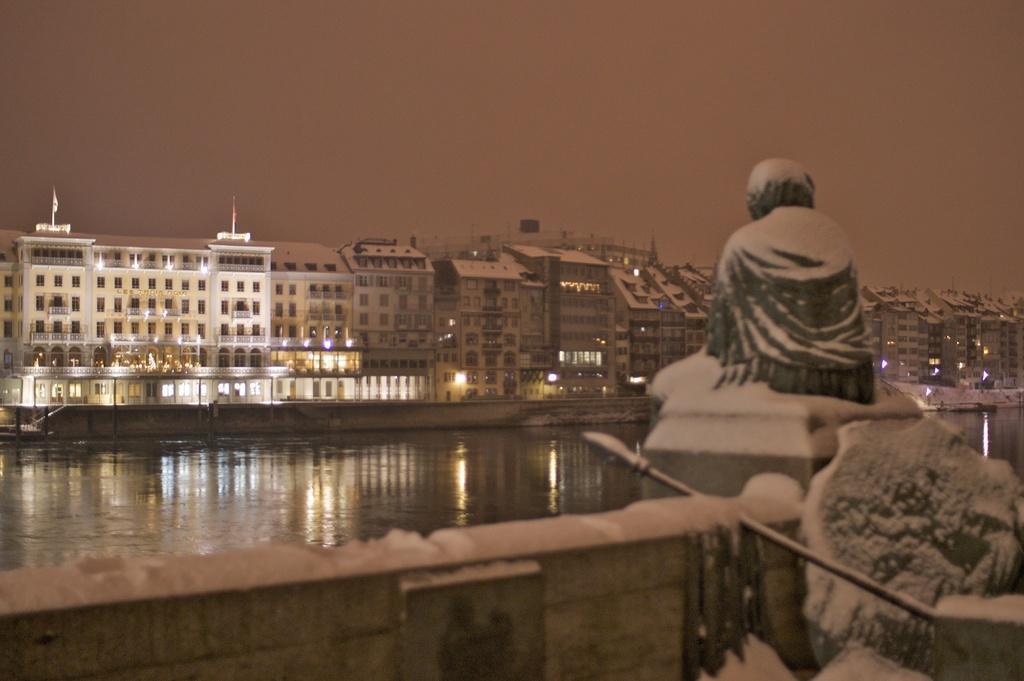What is the main subject in the image? There is a sculpture in the image. What else can be seen in the image besides the sculpture? There is a pole and objects on a platform in the image. What can be seen in the background of the image? Water, buildings, windows, and poles are visible in the background of the image. The sky is also visible. Can you see any eyes in the image? There are no eyes visible in the image. Is the water in the background of the image raining? The image does not show any rain, so it cannot be determined if the water is raining. 